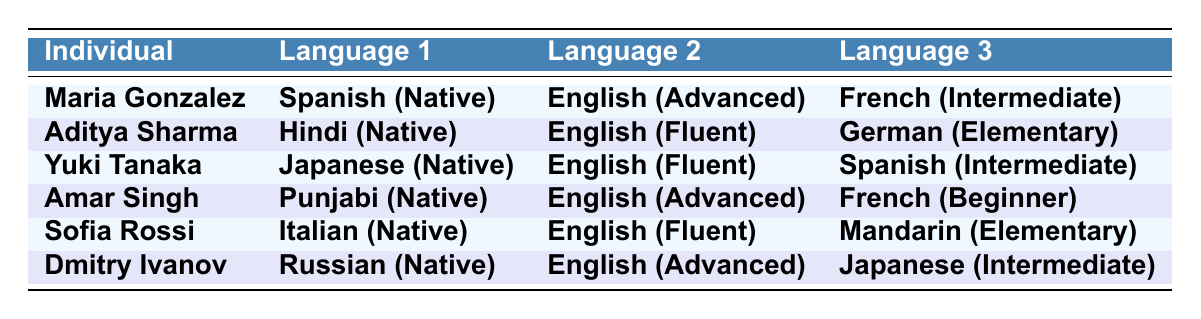What is the proficiency level of Maria Gonzalez in French? From the table, under Maria Gonzalez, the proficiency level listed for French is "Intermediate."
Answer: Intermediate How many individuals are fluent in English? By reviewing the table, Aditya Sharma, Yuki Tanaka, Sofia Rossi, and Dmitry Ivanov have "Fluent" listed as their proficiency level in English, totaling four individuals.
Answer: Four Which individual has the highest number of native languages? All individuals listed have only one native language, as indicated in the table. Therefore, none has more than one native language.
Answer: None Is Yuki Tanaka proficient in Spanish? Yes, the table indicates that Yuki Tanaka's proficiency level in Spanish is "Intermediate."
Answer: Yes What is the average proficiency level of all individuals in their native languages? All individuals are native in a single language, so calculating the average would not apply; they all have the same level of “Native.”
Answer: Not applicable Which languages have a proficiency level of "Elementary"? From the table, the languages with "Elementary" proficiency levels are German (Aditya Sharma) and Mandarin (Sofia Rossi).
Answer: German, Mandarin Are there any individuals who speak more than three languages? The table lists each individual with exactly three languages, as stated. Thus, no individual speaks more than three languages.
Answer: No Who has the highest proficiency in English? The proficiency levels in English for Maria Gonzalez, Aditya Sharma, Yuki Tanaka, Amar Singh, Sofia Rossi, and Dmitry Ivanov are "Advanced," "Fluent," or "Fluent." Both Maria and Dmitry have "Advanced."
Answer: Maria Gonzalez and Dmitry Ivanov What is the proficiency level of Amar Singh in French? The table indicates that Amar Singh has a "Beginner" proficiency level in French.
Answer: Beginner Which individual has all language proficiency levels at or above "Intermediate"? Reviewing the table, Dmitry Ivanov has "Native" in Russian, "Advanced" in English, and "Intermediate" in Japanese. No one else has language levels all above "Intermediate."
Answer: Dmitry Ivanov 